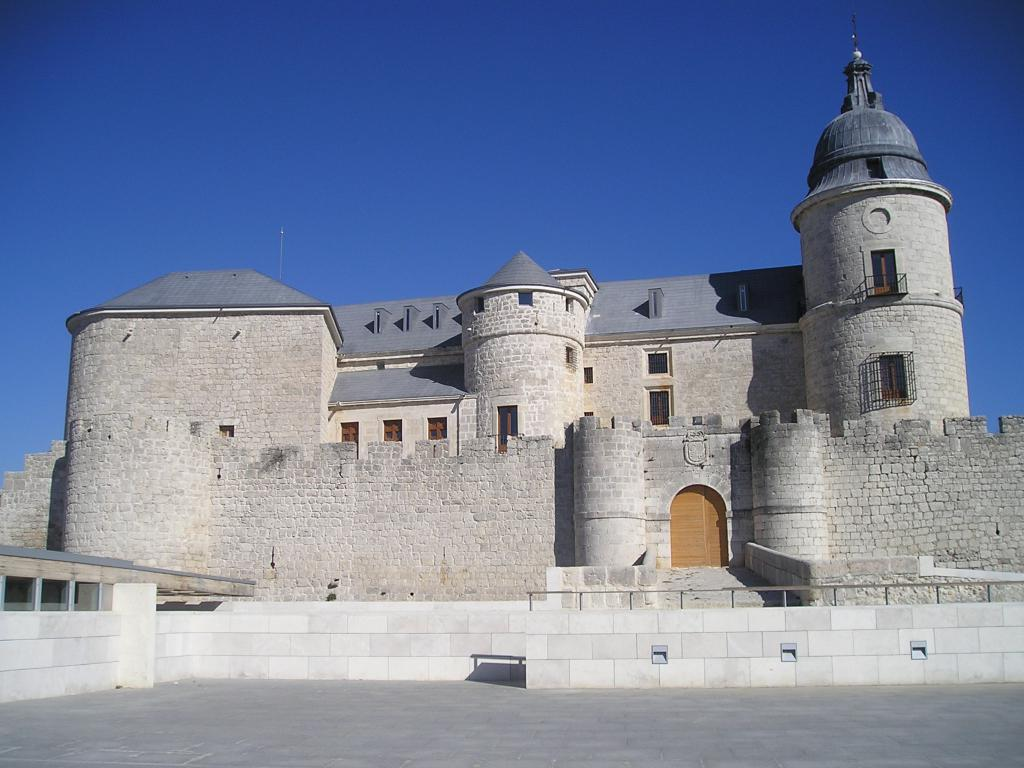What is the main structure in the image? There is a castle in the image. What can be seen in the background of the image? There is a sky visible in the background of the image. How is the distribution of electricity managed within the castle in the image? There is no information provided about the distribution of electricity within the castle, so it cannot be determined from the image. 